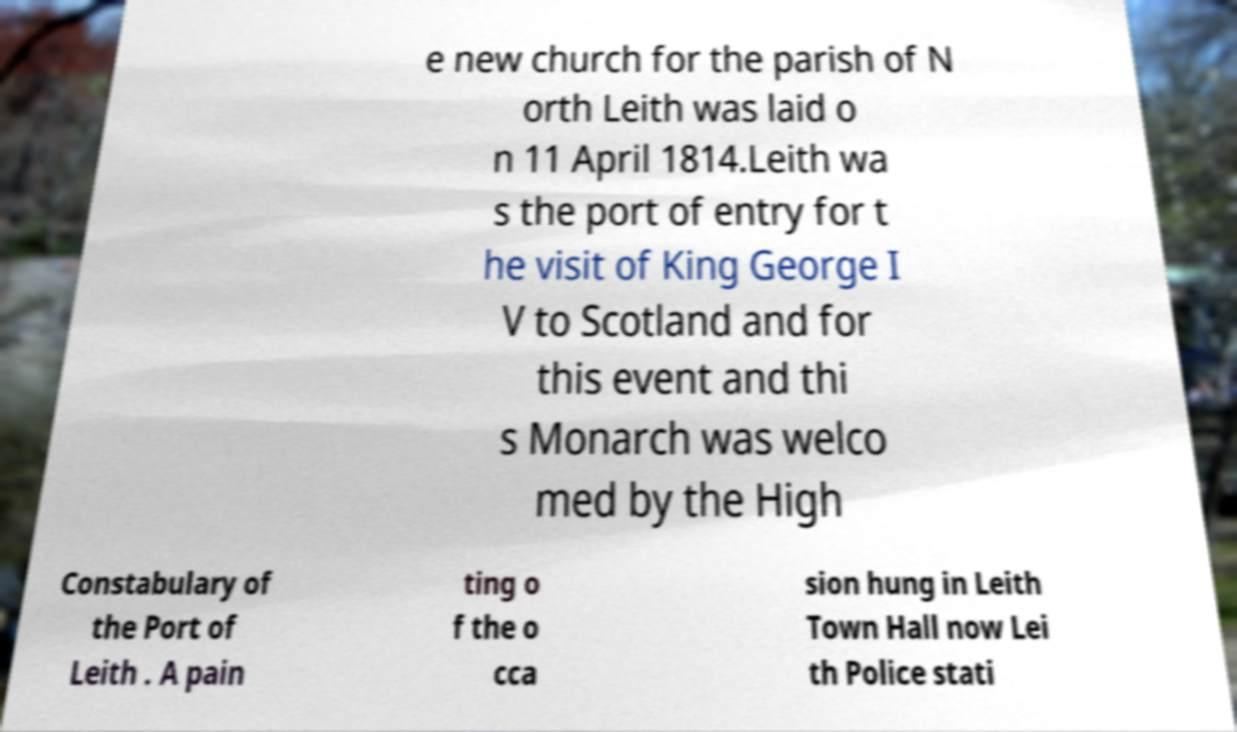Please read and relay the text visible in this image. What does it say? e new church for the parish of N orth Leith was laid o n 11 April 1814.Leith wa s the port of entry for t he visit of King George I V to Scotland and for this event and thi s Monarch was welco med by the High Constabulary of the Port of Leith . A pain ting o f the o cca sion hung in Leith Town Hall now Lei th Police stati 